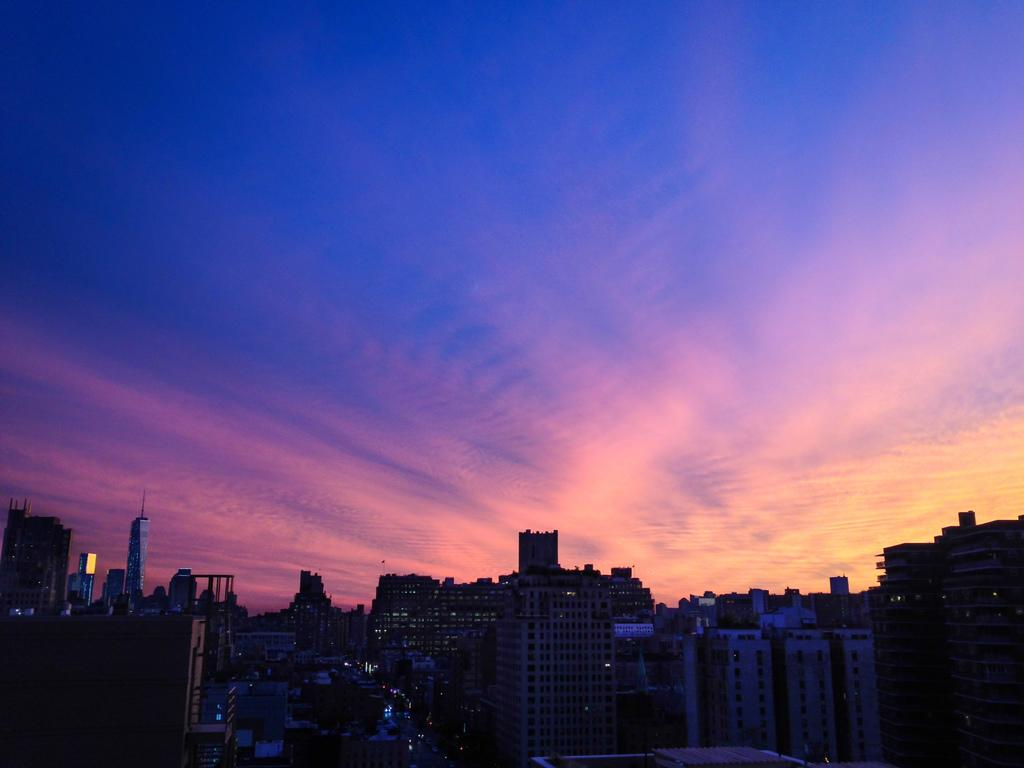What type of structures can be seen in the image? There are buildings in the image. What other natural elements are present in the image? There are trees in the image. What type of man-made paths are visible in the image? There are roads in the image. What type of transportation is present in the image? There are vehicles in the image. What is visible in the upper part of the image? The sky is visible in the image. What can be observed in the sky? Clouds are present in the sky. What type of chain is holding the protest in the image? There is no protest or chain present in the image. What type of voice can be heard coming from the vehicles in the image? There is no indication of any voice or sound in the image, as it only shows buildings, trees, roads, vehicles, and the sky. 